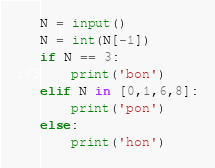<code> <loc_0><loc_0><loc_500><loc_500><_Python_>N = input()
N = int(N[-1])
if N == 3:
    print('bon')
elif N in [0,1,6,8]:
    print('pon')
else:
    print('hon')
</code> 